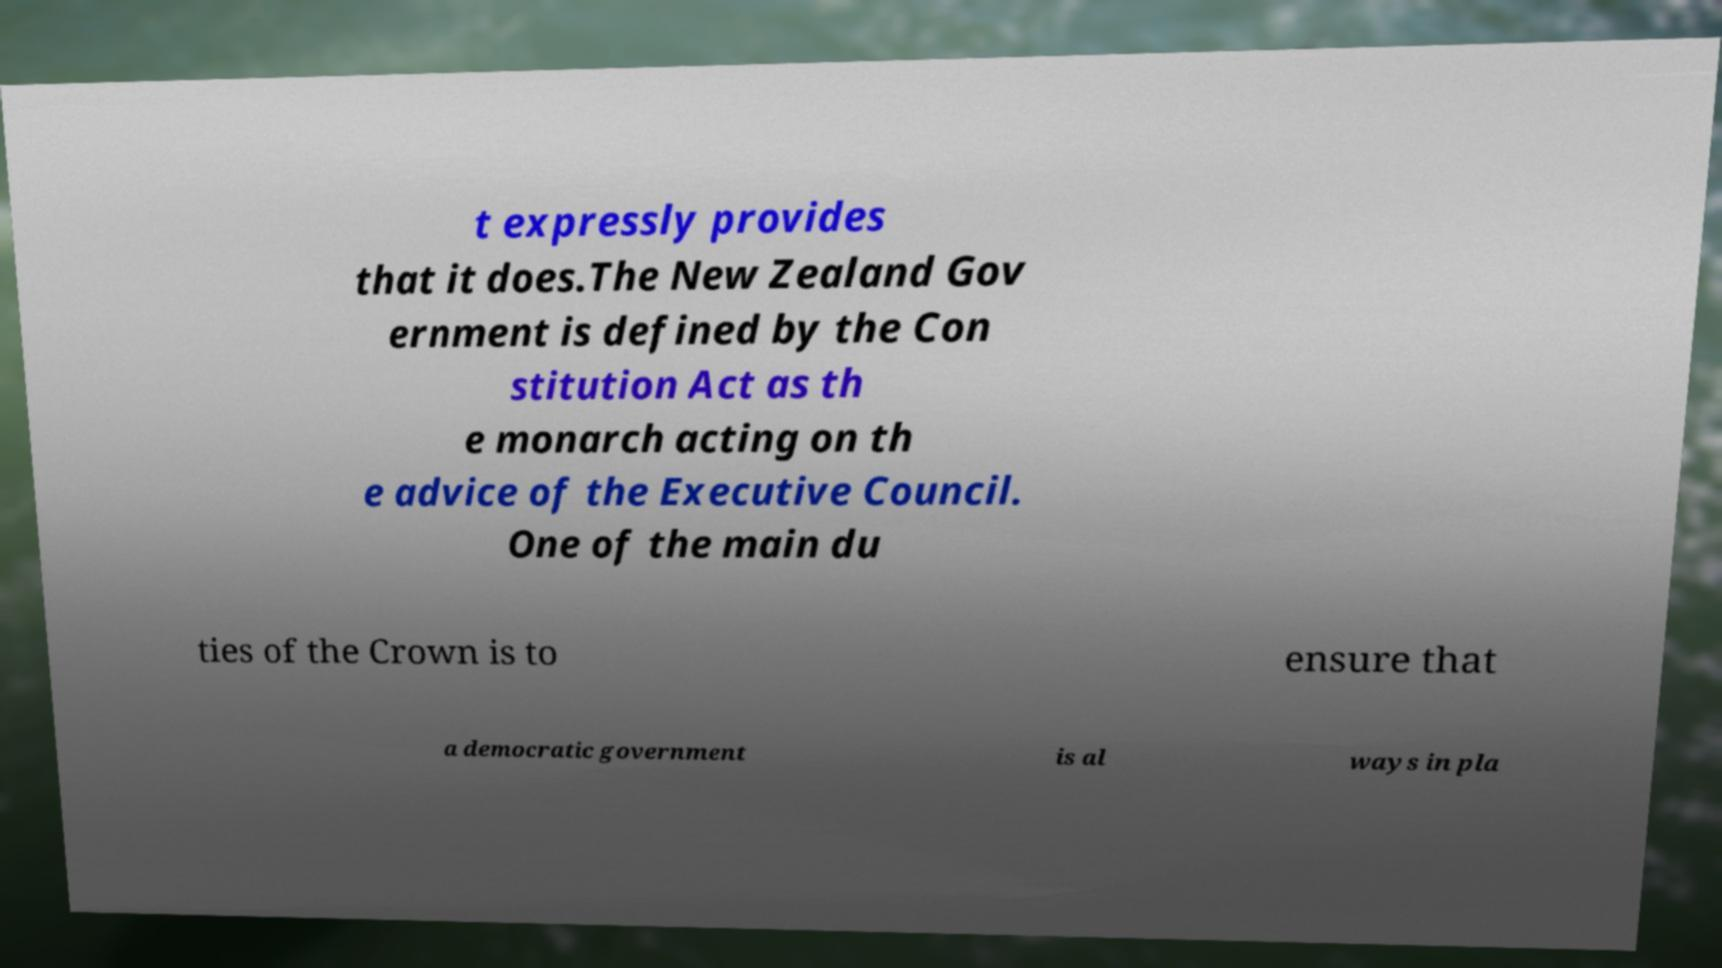Could you extract and type out the text from this image? t expressly provides that it does.The New Zealand Gov ernment is defined by the Con stitution Act as th e monarch acting on th e advice of the Executive Council. One of the main du ties of the Crown is to ensure that a democratic government is al ways in pla 